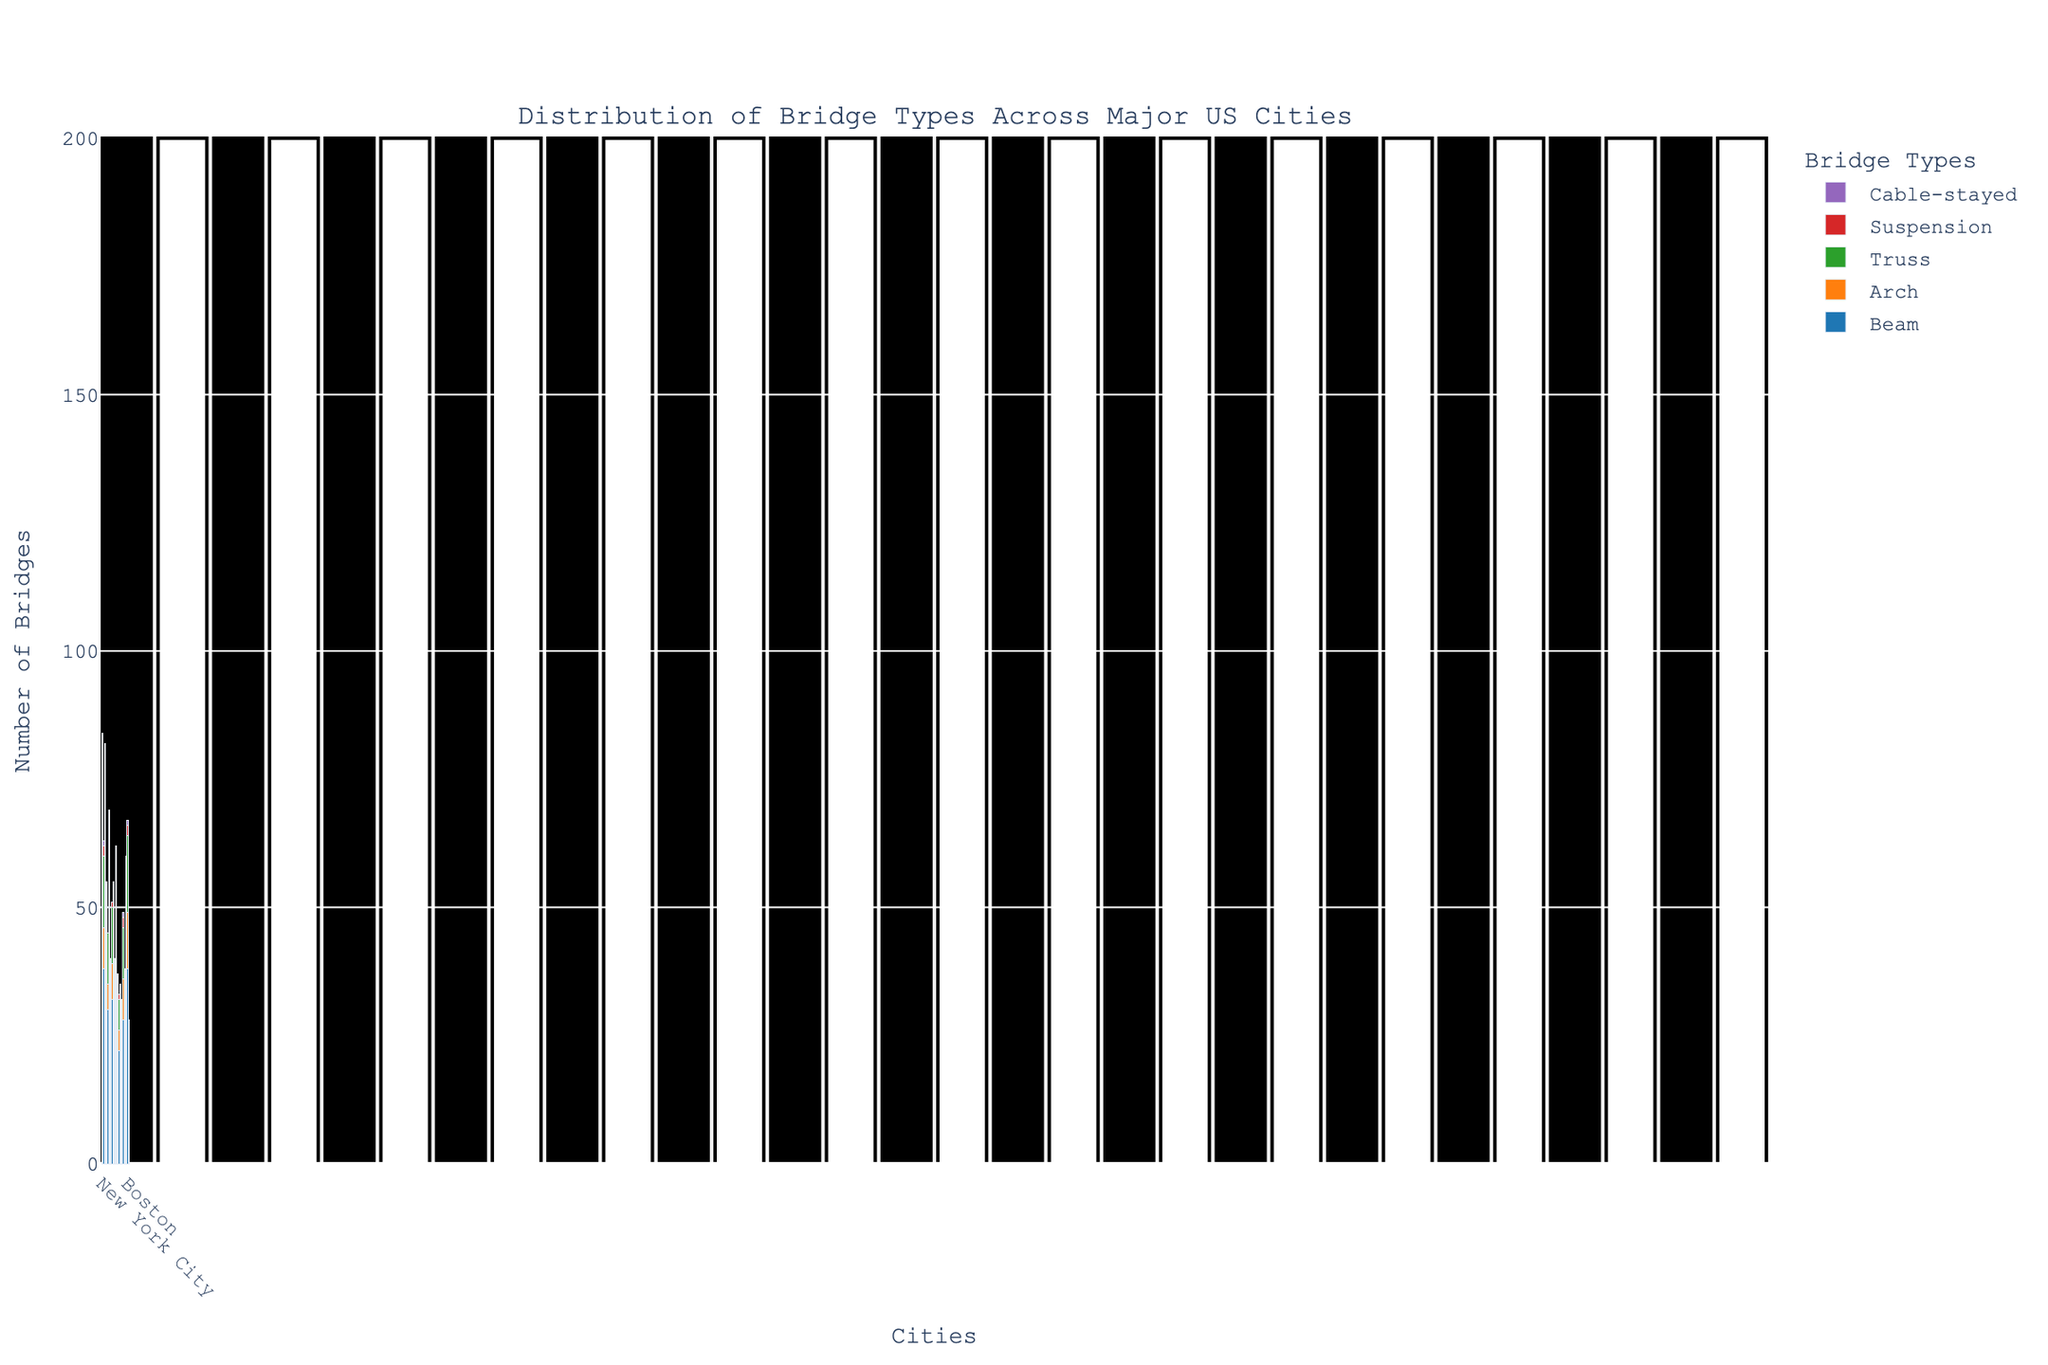Which city has the highest number of Truss bridges? By looking at the heights of the bars for Truss bridges, Chicago has the highest bar.
Answer: Chicago What is the total number of Beam bridges in New York City and Los Angeles? In New York City, there are 45 Beam bridges, and in Los Angeles, there are 38. Adding them gives 45 + 38 = 83.
Answer: 83 Which city has more Cable-stayed bridges, San Francisco or Boston? The height of the Cable-stayed bar for San Francisco is slightly higher than for Boston.
Answer: San Francisco What is the sum of Arch bridges in Houston, Phoenix, and San Antonio? The number of Arch bridges is 6 for Houston, 5 for Phoenix, and 4 for San Antonio. Their sum is 6 + 5 + 4 = 15.
Answer: 15 Which bridge type has the lowest overall count across all cities? By visually comparing all the bar segments of different colors for each bridge type, Cable-stayed bridges have the fewest bars overall.
Answer: Cable-stayed What is the average number of Suspension bridges across all cities? Sum all Suspension bridges: 6 (NYC) + 2 (LA) + 3 (Chicago) + 1 (Houston) + 0 (Phoenix) + 2 (Philadelphia) + 0 (San Antonio) + 1 (San Diego) + 0 (Dallas) + 0 (San Jose) + 4 (San Francisco) + 1 (Austin) + 1 (Jacksonville) + 0 (Fort Worth) + 0 (Columbus) + 2 (Seattle) + 1 (Denver) + 1 (Washington D.C.) + 2 (Boston) + 0 (Nashville) = 27. There are 20 cities, so the average is 27 / 20 = 1.35.
Answer: 1.35 Which city has an equal number of Arch and Truss bridges? By examining the data, Houston has 6 Arch and 6 Truss bridges.
Answer: Houston Compare the number of Beam bridges in Seattle and Denver. Which city has more? Visually comparing the heights of the Beam bars, Seattle's bar is higher than Denver's.
Answer: Seattle What is the difference in the number of Beam bridges between Boston and Nashville? Boston has 38 Beam bridges, while Nashville has 18. The difference is 38 - 18 = 20.
Answer: 20 In which city do Cable-stayed bridges outnumber Suspension bridges? By visually inspecting, each city's bars: New York City, Los Angeles, Chicago, Houston, Phoenix, Philadelphia, etc., none of them have Cable-stayed bridges outnumbering Suspension bridges.
Answer: None 